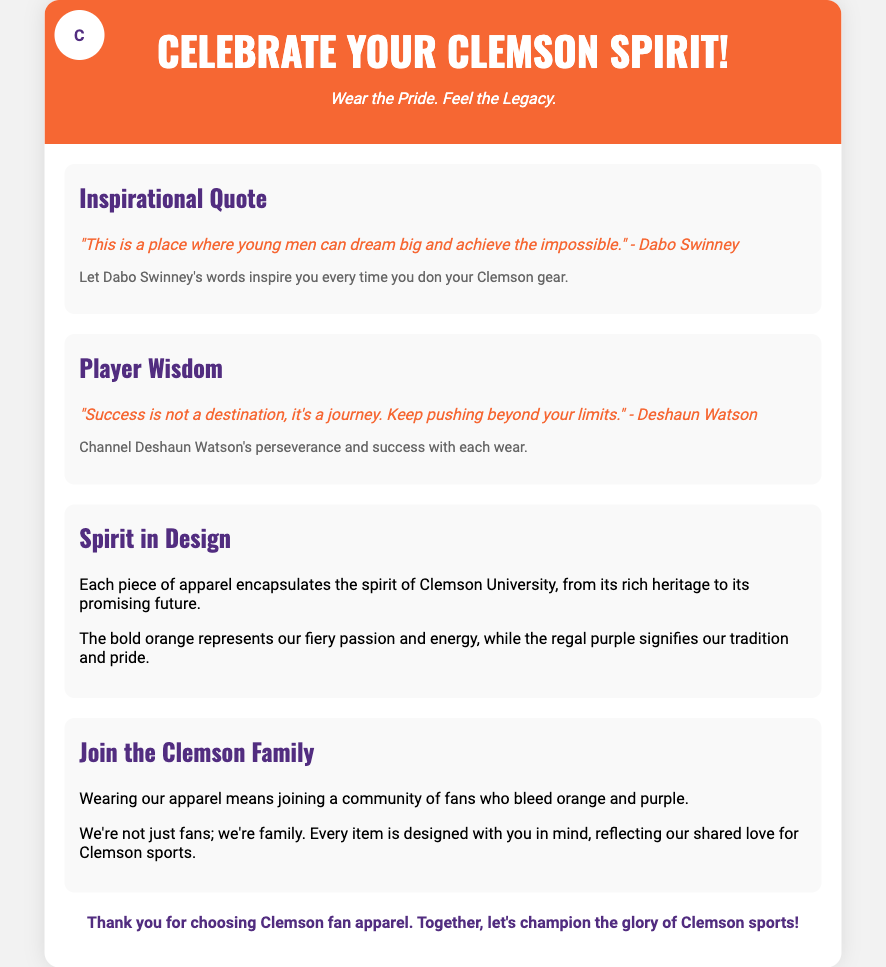what is the main focus of the packaging? The packaging emphasizes celebrating Clemson spirit through fan apparel.
Answer: Celebrate Your Clemson Spirit! who is quoted in the inspirational quote section? The quote in the inspirational quote section is attributed to a well-known Clemson coach.
Answer: Dabo Swinney what does the orange color represent in the apparel design? The orange color in the apparel symbolizes the energy and passion of Clemson.
Answer: Fiery passion and energy what type of community does wearing the apparel imply joining? The document mentions a specific type of community that relates to fans of Clemson.
Answer: Clemson family what does Deshaun Watson's quote suggest about success? The quote requires understanding and reflects a perspective on success highlighted by a former player.
Answer: It's a journey how is the overall spirit of Clemson University depicted in the apparel? The apparel is designed to encapsulate specific elements of Clemson's identity and future.
Answer: Rich heritage and promising future how does the document suggest fans feel when they wear the apparel? The document describes feelings associated with wearing the apparel and being part of a community.
Answer: Pride and belonging what is the color scheme of the Clemson apparel? The document specifies the key colors that represent Clemson's branding.
Answer: Orange and purple what is included in the slogan of the header? The slogan encapsulates the essence of the brand and the feeling towards the apparel.
Answer: Wear the Pride. Feel the Legacy 